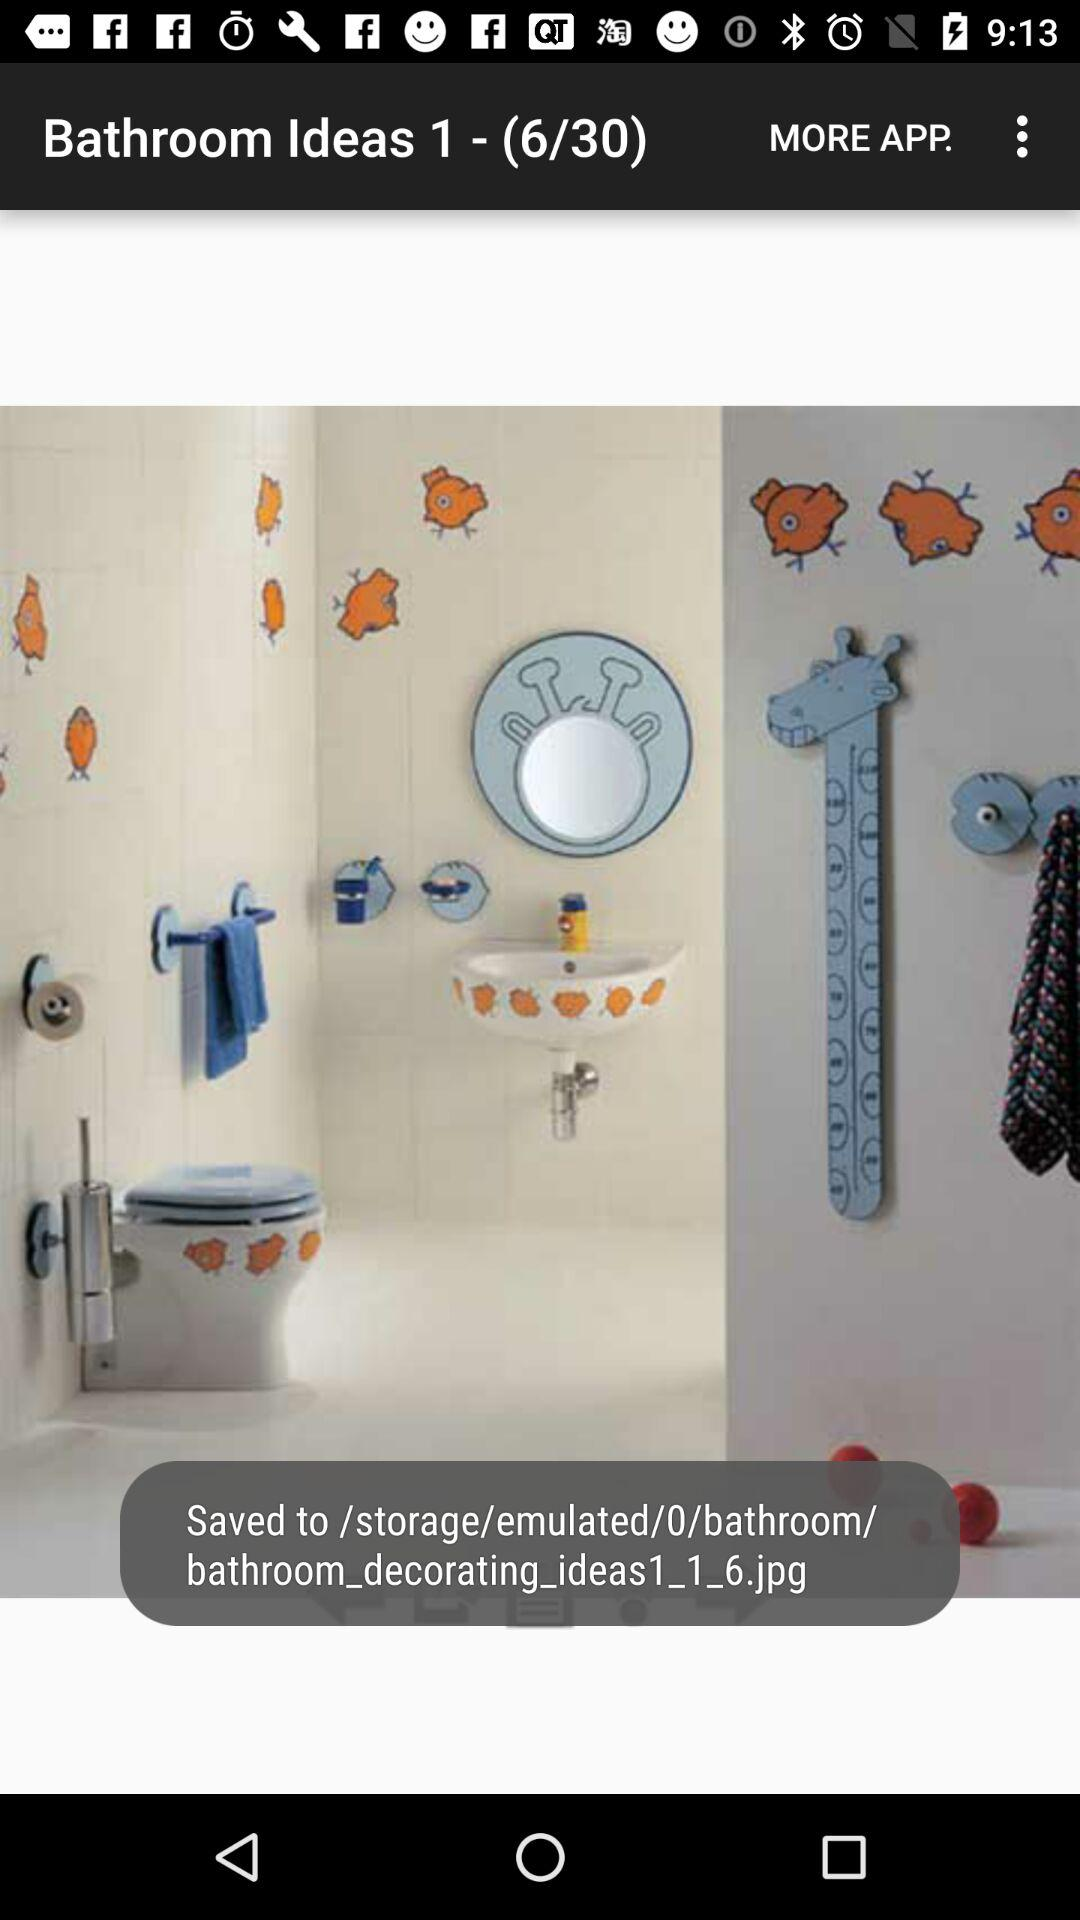How many images in total are there? There are 30 images. 